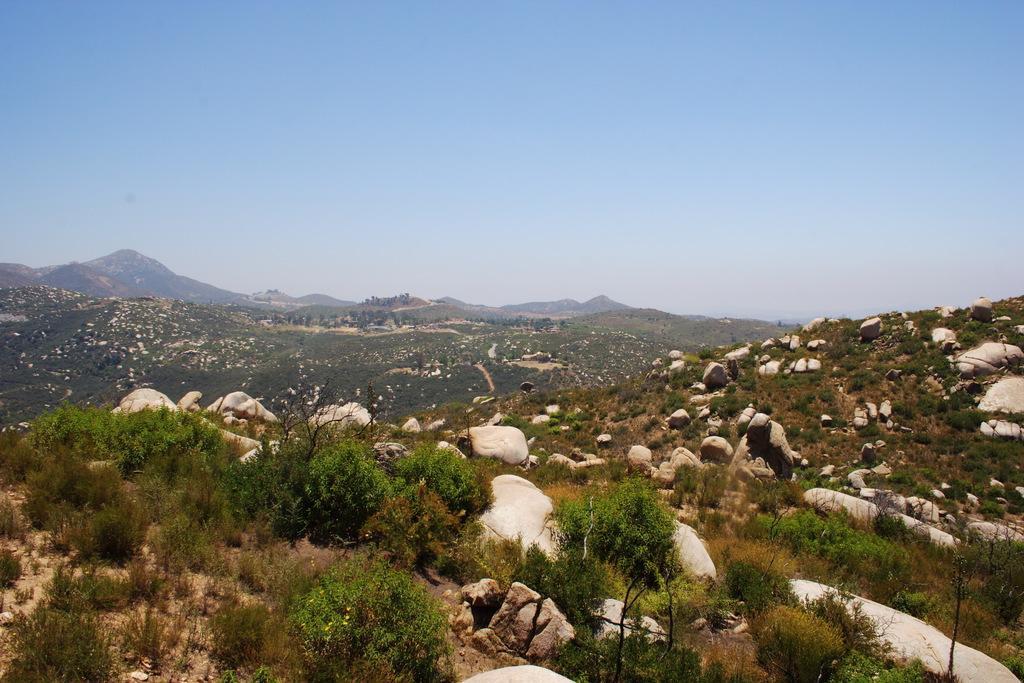Can you describe this image briefly? In this image there are rocks, trees, hills, and in the background there is sky. 